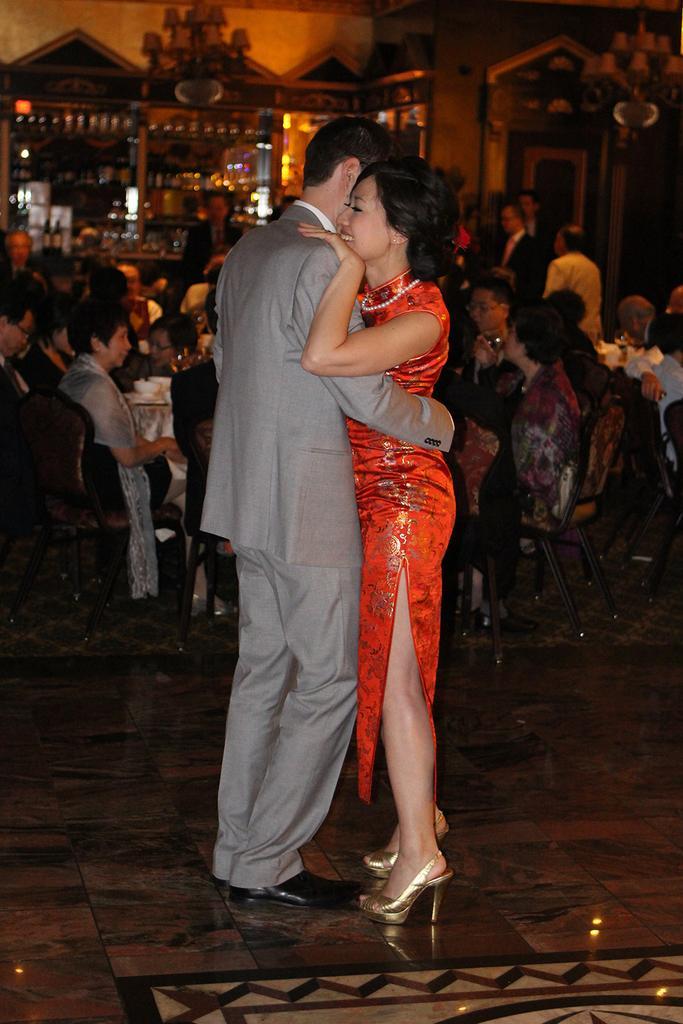Please provide a concise description of this image. In the center of the image there is a man wearing a grey color suit and a lady wearing a red color dress. At the background of the image there are many people sitting on chairs and there is a wall. 